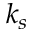<formula> <loc_0><loc_0><loc_500><loc_500>k _ { s }</formula> 